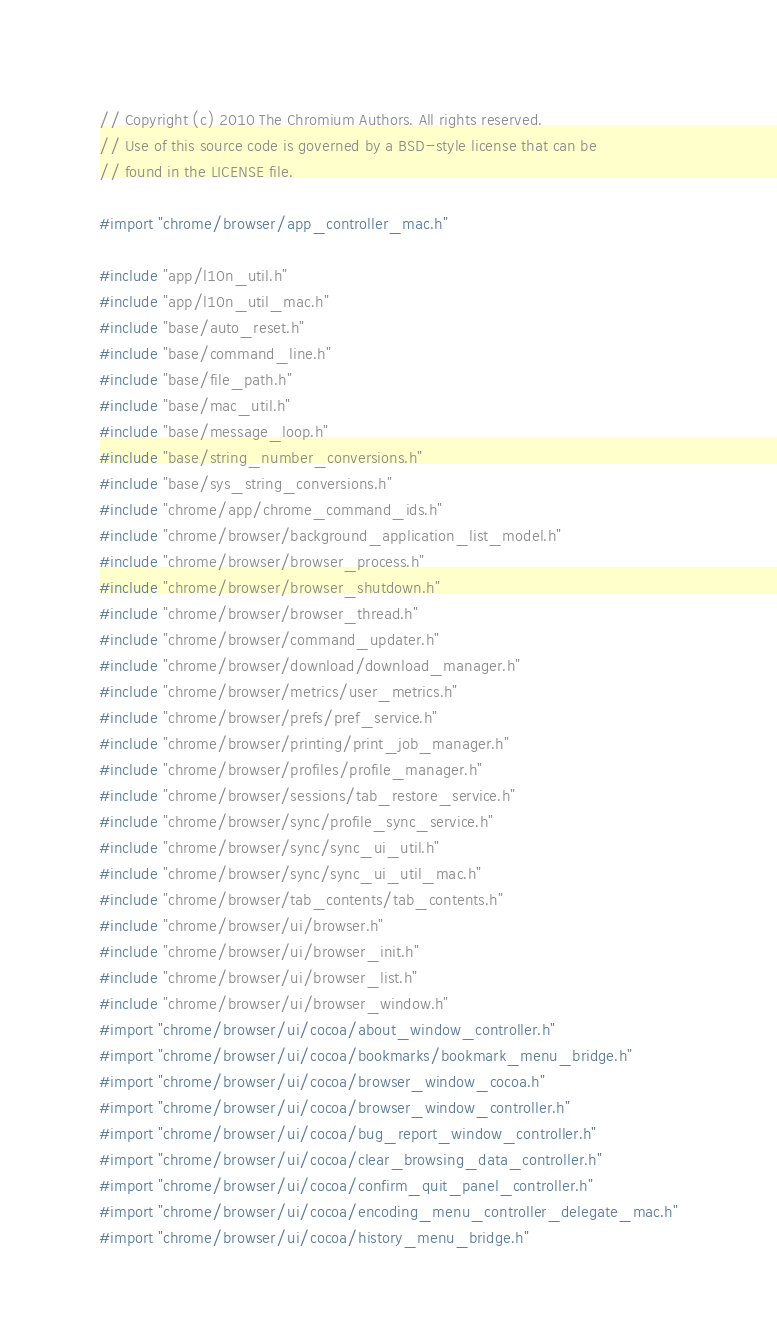Convert code to text. <code><loc_0><loc_0><loc_500><loc_500><_ObjectiveC_>// Copyright (c) 2010 The Chromium Authors. All rights reserved.
// Use of this source code is governed by a BSD-style license that can be
// found in the LICENSE file.

#import "chrome/browser/app_controller_mac.h"

#include "app/l10n_util.h"
#include "app/l10n_util_mac.h"
#include "base/auto_reset.h"
#include "base/command_line.h"
#include "base/file_path.h"
#include "base/mac_util.h"
#include "base/message_loop.h"
#include "base/string_number_conversions.h"
#include "base/sys_string_conversions.h"
#include "chrome/app/chrome_command_ids.h"
#include "chrome/browser/background_application_list_model.h"
#include "chrome/browser/browser_process.h"
#include "chrome/browser/browser_shutdown.h"
#include "chrome/browser/browser_thread.h"
#include "chrome/browser/command_updater.h"
#include "chrome/browser/download/download_manager.h"
#include "chrome/browser/metrics/user_metrics.h"
#include "chrome/browser/prefs/pref_service.h"
#include "chrome/browser/printing/print_job_manager.h"
#include "chrome/browser/profiles/profile_manager.h"
#include "chrome/browser/sessions/tab_restore_service.h"
#include "chrome/browser/sync/profile_sync_service.h"
#include "chrome/browser/sync/sync_ui_util.h"
#include "chrome/browser/sync/sync_ui_util_mac.h"
#include "chrome/browser/tab_contents/tab_contents.h"
#include "chrome/browser/ui/browser.h"
#include "chrome/browser/ui/browser_init.h"
#include "chrome/browser/ui/browser_list.h"
#include "chrome/browser/ui/browser_window.h"
#import "chrome/browser/ui/cocoa/about_window_controller.h"
#import "chrome/browser/ui/cocoa/bookmarks/bookmark_menu_bridge.h"
#import "chrome/browser/ui/cocoa/browser_window_cocoa.h"
#import "chrome/browser/ui/cocoa/browser_window_controller.h"
#import "chrome/browser/ui/cocoa/bug_report_window_controller.h"
#import "chrome/browser/ui/cocoa/clear_browsing_data_controller.h"
#import "chrome/browser/ui/cocoa/confirm_quit_panel_controller.h"
#import "chrome/browser/ui/cocoa/encoding_menu_controller_delegate_mac.h"
#import "chrome/browser/ui/cocoa/history_menu_bridge.h"</code> 